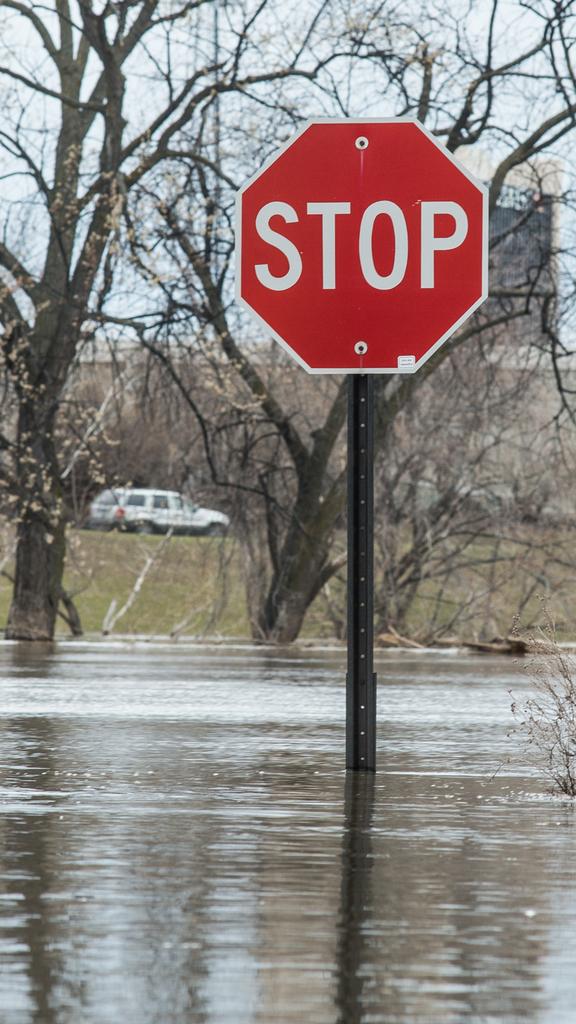What is the sign telling us to do?
Your response must be concise. Stop. 